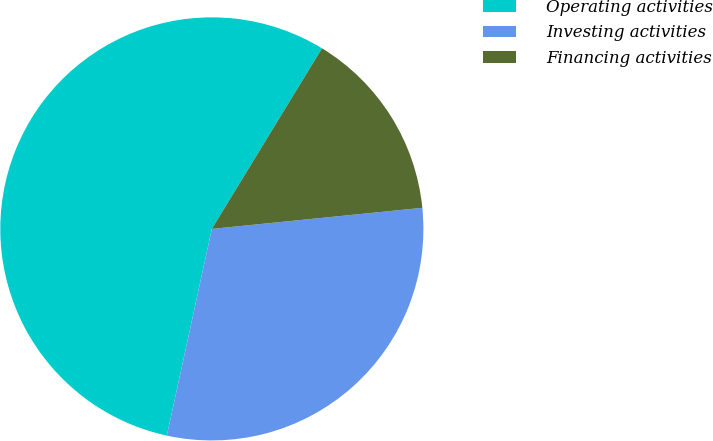Convert chart to OTSL. <chart><loc_0><loc_0><loc_500><loc_500><pie_chart><fcel>Operating activities<fcel>Investing activities<fcel>Financing activities<nl><fcel>55.3%<fcel>30.0%<fcel>14.69%<nl></chart> 